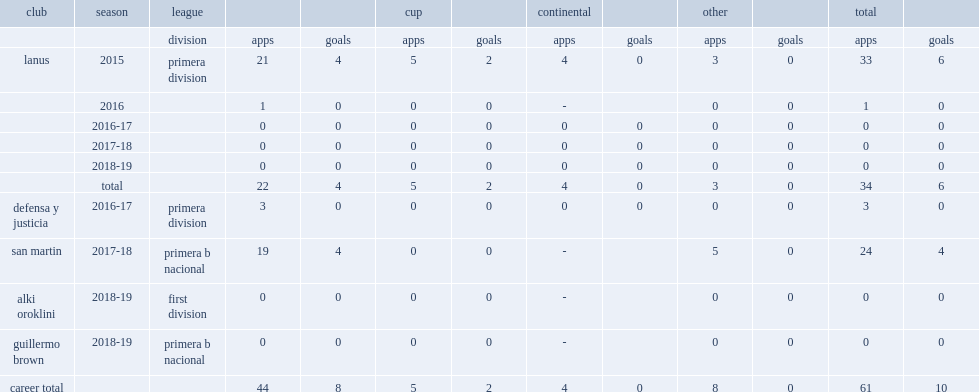Which club did sergio fabian gonzalez join in primera division in 2016. Defensa y justicia. 